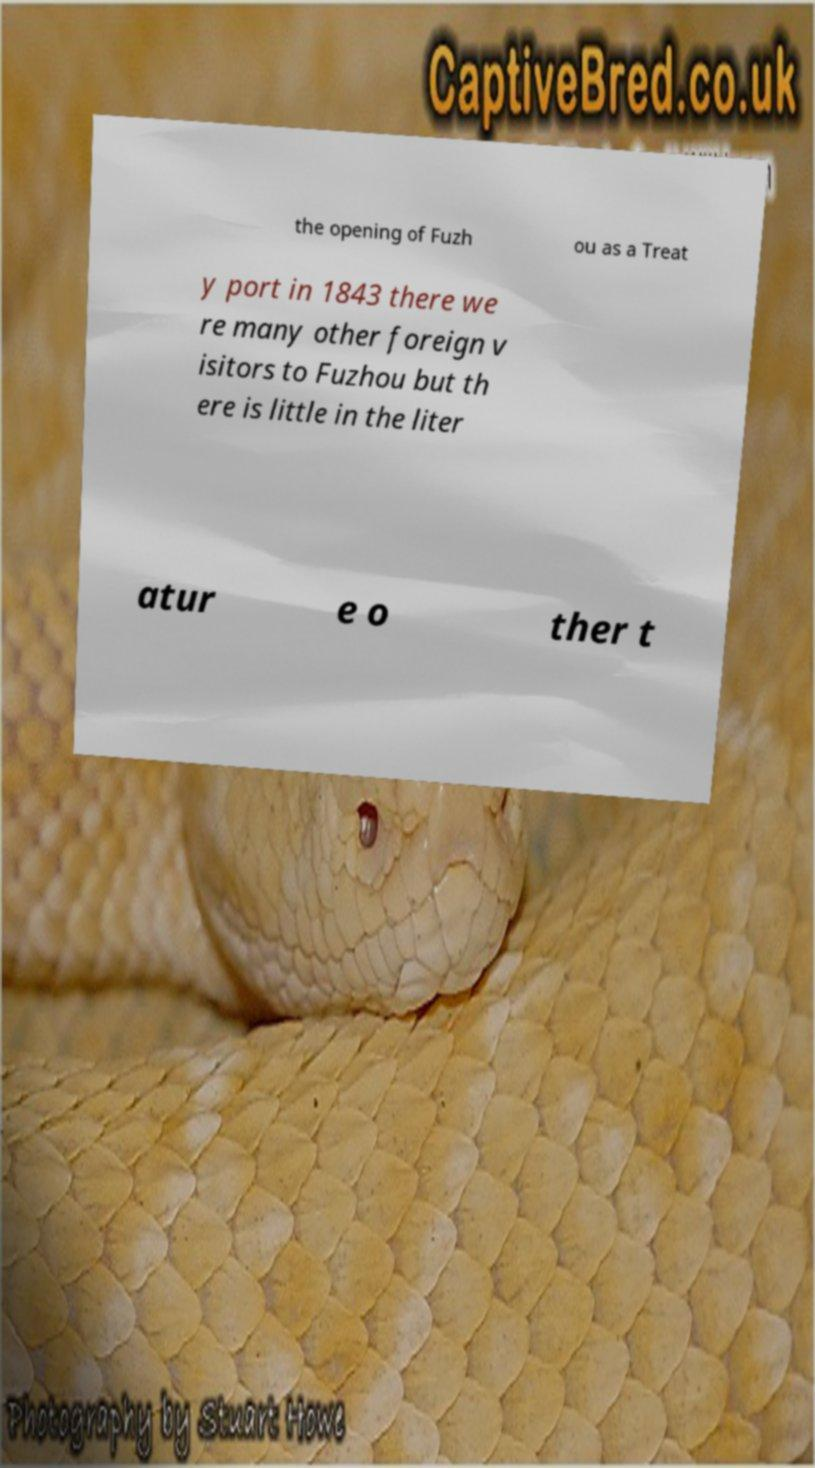Please read and relay the text visible in this image. What does it say? the opening of Fuzh ou as a Treat y port in 1843 there we re many other foreign v isitors to Fuzhou but th ere is little in the liter atur e o ther t 